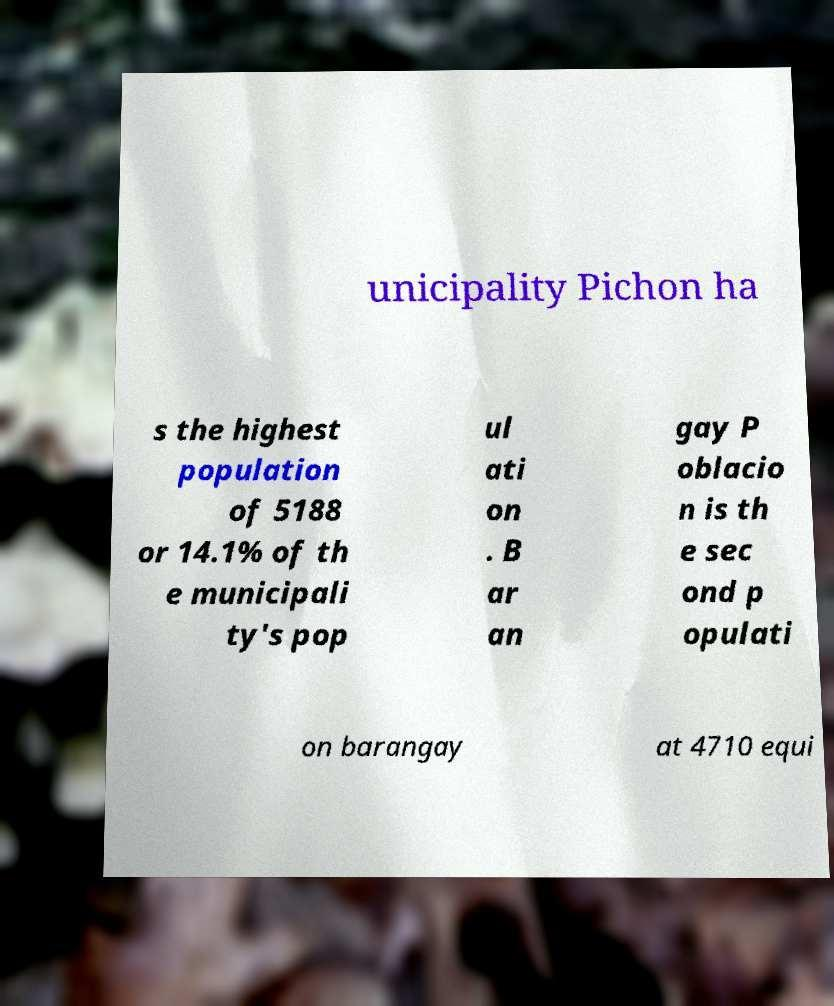There's text embedded in this image that I need extracted. Can you transcribe it verbatim? unicipality Pichon ha s the highest population of 5188 or 14.1% of th e municipali ty's pop ul ati on . B ar an gay P oblacio n is th e sec ond p opulati on barangay at 4710 equi 